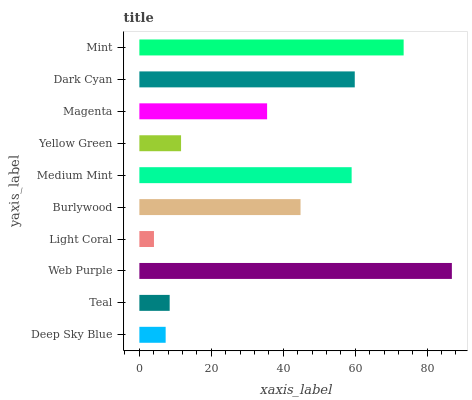Is Light Coral the minimum?
Answer yes or no. Yes. Is Web Purple the maximum?
Answer yes or no. Yes. Is Teal the minimum?
Answer yes or no. No. Is Teal the maximum?
Answer yes or no. No. Is Teal greater than Deep Sky Blue?
Answer yes or no. Yes. Is Deep Sky Blue less than Teal?
Answer yes or no. Yes. Is Deep Sky Blue greater than Teal?
Answer yes or no. No. Is Teal less than Deep Sky Blue?
Answer yes or no. No. Is Burlywood the high median?
Answer yes or no. Yes. Is Magenta the low median?
Answer yes or no. Yes. Is Light Coral the high median?
Answer yes or no. No. Is Light Coral the low median?
Answer yes or no. No. 